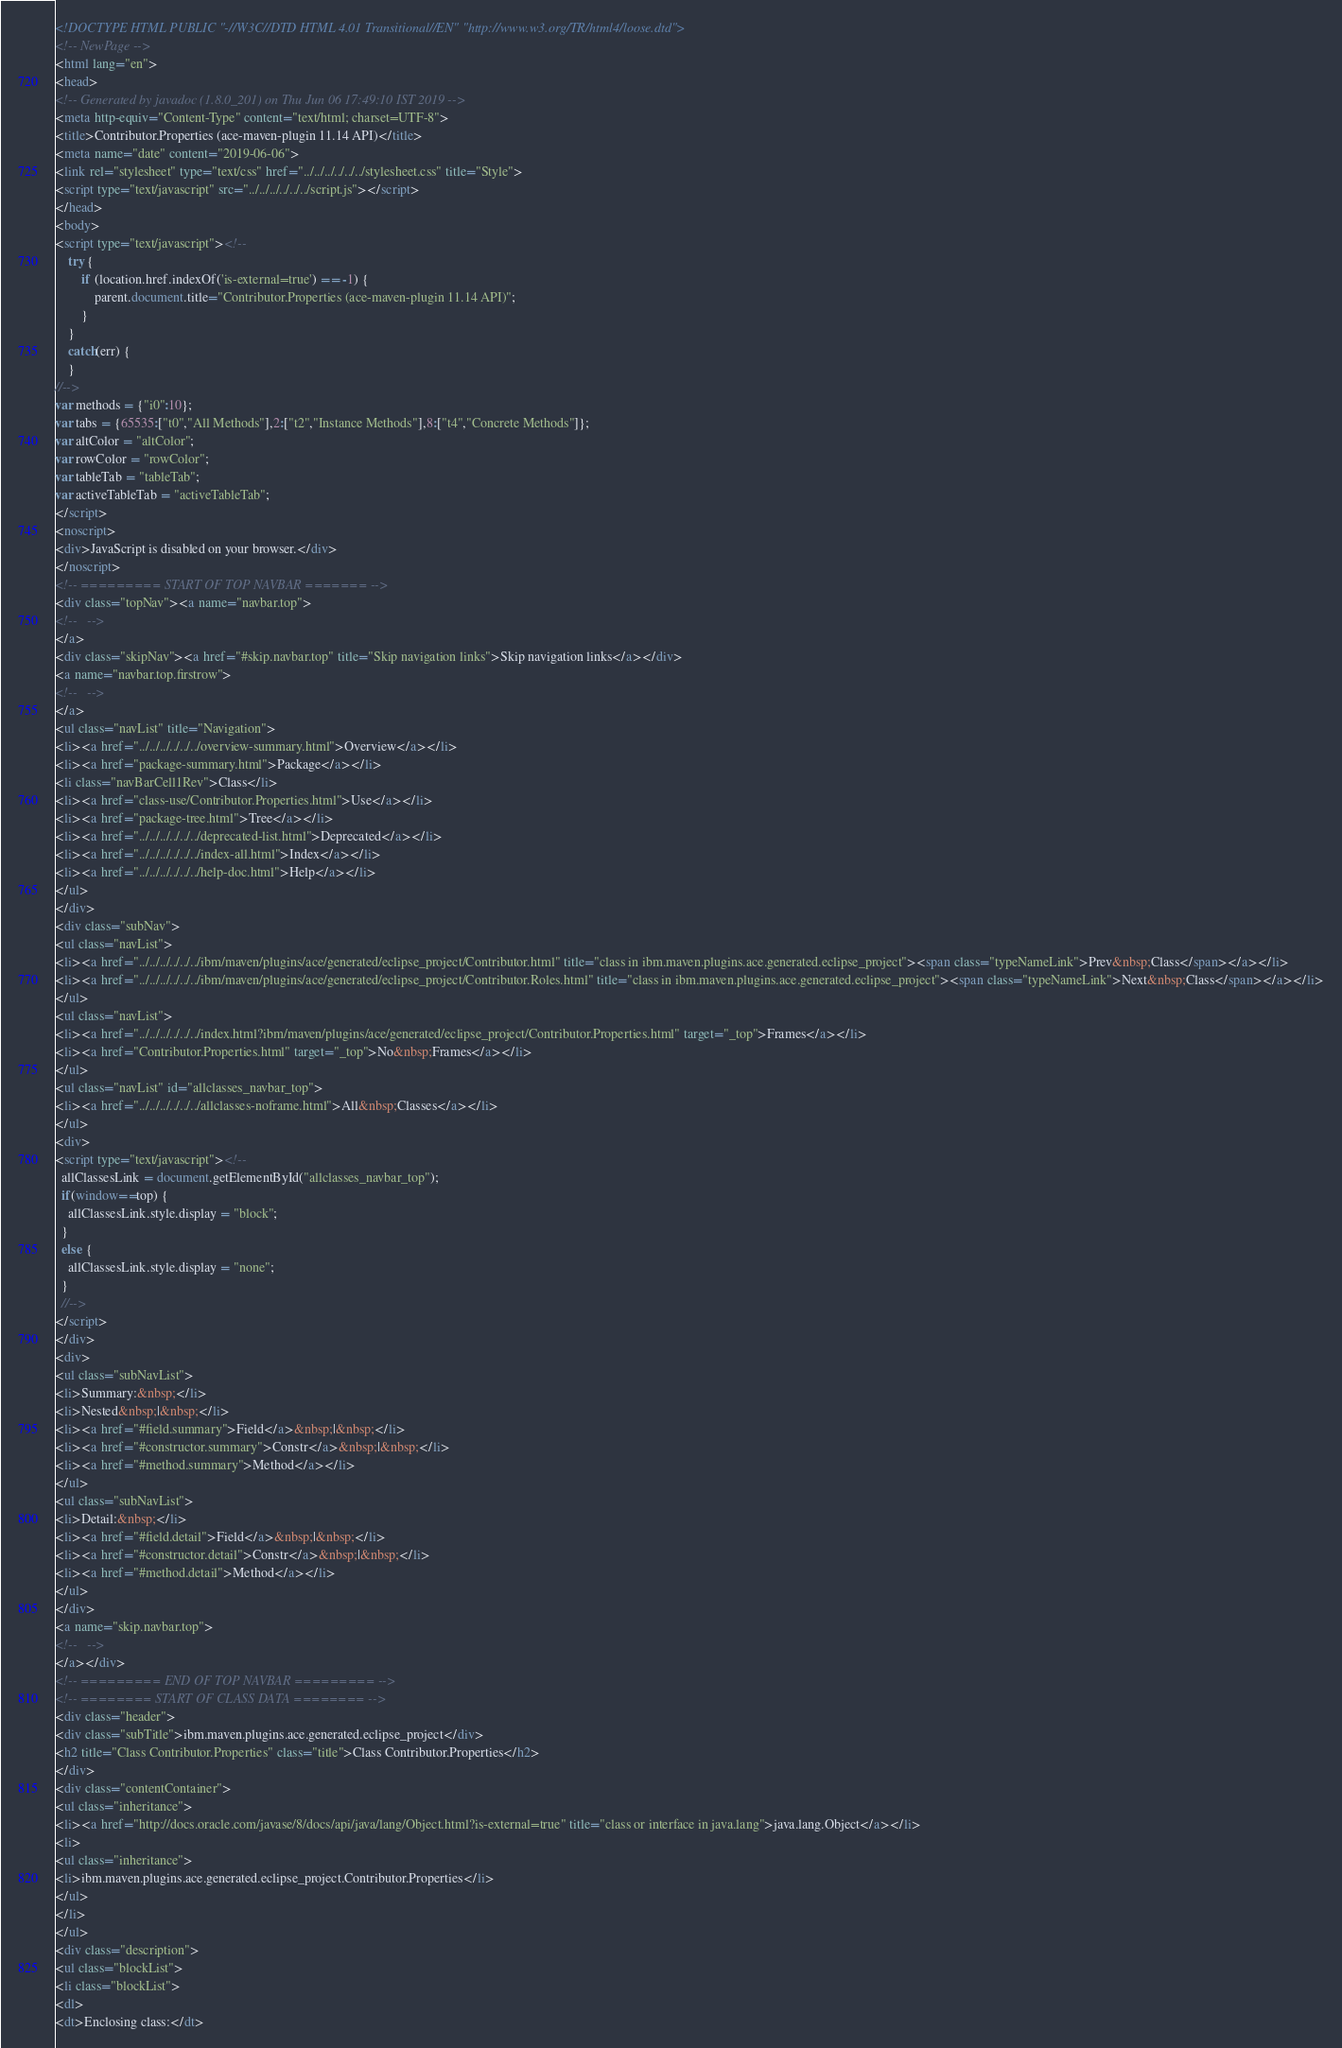<code> <loc_0><loc_0><loc_500><loc_500><_HTML_><!DOCTYPE HTML PUBLIC "-//W3C//DTD HTML 4.01 Transitional//EN" "http://www.w3.org/TR/html4/loose.dtd">
<!-- NewPage -->
<html lang="en">
<head>
<!-- Generated by javadoc (1.8.0_201) on Thu Jun 06 17:49:10 IST 2019 -->
<meta http-equiv="Content-Type" content="text/html; charset=UTF-8">
<title>Contributor.Properties (ace-maven-plugin 11.14 API)</title>
<meta name="date" content="2019-06-06">
<link rel="stylesheet" type="text/css" href="../../../../../../stylesheet.css" title="Style">
<script type="text/javascript" src="../../../../../../script.js"></script>
</head>
<body>
<script type="text/javascript"><!--
    try {
        if (location.href.indexOf('is-external=true') == -1) {
            parent.document.title="Contributor.Properties (ace-maven-plugin 11.14 API)";
        }
    }
    catch(err) {
    }
//-->
var methods = {"i0":10};
var tabs = {65535:["t0","All Methods"],2:["t2","Instance Methods"],8:["t4","Concrete Methods"]};
var altColor = "altColor";
var rowColor = "rowColor";
var tableTab = "tableTab";
var activeTableTab = "activeTableTab";
</script>
<noscript>
<div>JavaScript is disabled on your browser.</div>
</noscript>
<!-- ========= START OF TOP NAVBAR ======= -->
<div class="topNav"><a name="navbar.top">
<!--   -->
</a>
<div class="skipNav"><a href="#skip.navbar.top" title="Skip navigation links">Skip navigation links</a></div>
<a name="navbar.top.firstrow">
<!--   -->
</a>
<ul class="navList" title="Navigation">
<li><a href="../../../../../../overview-summary.html">Overview</a></li>
<li><a href="package-summary.html">Package</a></li>
<li class="navBarCell1Rev">Class</li>
<li><a href="class-use/Contributor.Properties.html">Use</a></li>
<li><a href="package-tree.html">Tree</a></li>
<li><a href="../../../../../../deprecated-list.html">Deprecated</a></li>
<li><a href="../../../../../../index-all.html">Index</a></li>
<li><a href="../../../../../../help-doc.html">Help</a></li>
</ul>
</div>
<div class="subNav">
<ul class="navList">
<li><a href="../../../../../../ibm/maven/plugins/ace/generated/eclipse_project/Contributor.html" title="class in ibm.maven.plugins.ace.generated.eclipse_project"><span class="typeNameLink">Prev&nbsp;Class</span></a></li>
<li><a href="../../../../../../ibm/maven/plugins/ace/generated/eclipse_project/Contributor.Roles.html" title="class in ibm.maven.plugins.ace.generated.eclipse_project"><span class="typeNameLink">Next&nbsp;Class</span></a></li>
</ul>
<ul class="navList">
<li><a href="../../../../../../index.html?ibm/maven/plugins/ace/generated/eclipse_project/Contributor.Properties.html" target="_top">Frames</a></li>
<li><a href="Contributor.Properties.html" target="_top">No&nbsp;Frames</a></li>
</ul>
<ul class="navList" id="allclasses_navbar_top">
<li><a href="../../../../../../allclasses-noframe.html">All&nbsp;Classes</a></li>
</ul>
<div>
<script type="text/javascript"><!--
  allClassesLink = document.getElementById("allclasses_navbar_top");
  if(window==top) {
    allClassesLink.style.display = "block";
  }
  else {
    allClassesLink.style.display = "none";
  }
  //-->
</script>
</div>
<div>
<ul class="subNavList">
<li>Summary:&nbsp;</li>
<li>Nested&nbsp;|&nbsp;</li>
<li><a href="#field.summary">Field</a>&nbsp;|&nbsp;</li>
<li><a href="#constructor.summary">Constr</a>&nbsp;|&nbsp;</li>
<li><a href="#method.summary">Method</a></li>
</ul>
<ul class="subNavList">
<li>Detail:&nbsp;</li>
<li><a href="#field.detail">Field</a>&nbsp;|&nbsp;</li>
<li><a href="#constructor.detail">Constr</a>&nbsp;|&nbsp;</li>
<li><a href="#method.detail">Method</a></li>
</ul>
</div>
<a name="skip.navbar.top">
<!--   -->
</a></div>
<!-- ========= END OF TOP NAVBAR ========= -->
<!-- ======== START OF CLASS DATA ======== -->
<div class="header">
<div class="subTitle">ibm.maven.plugins.ace.generated.eclipse_project</div>
<h2 title="Class Contributor.Properties" class="title">Class Contributor.Properties</h2>
</div>
<div class="contentContainer">
<ul class="inheritance">
<li><a href="http://docs.oracle.com/javase/8/docs/api/java/lang/Object.html?is-external=true" title="class or interface in java.lang">java.lang.Object</a></li>
<li>
<ul class="inheritance">
<li>ibm.maven.plugins.ace.generated.eclipse_project.Contributor.Properties</li>
</ul>
</li>
</ul>
<div class="description">
<ul class="blockList">
<li class="blockList">
<dl>
<dt>Enclosing class:</dt></code> 